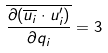Convert formula to latex. <formula><loc_0><loc_0><loc_500><loc_500>\overline { \frac { \partial ( \overline { u _ { i } } \cdot u _ { i } ^ { \prime } ) } { \partial q _ { i } } } = 3</formula> 